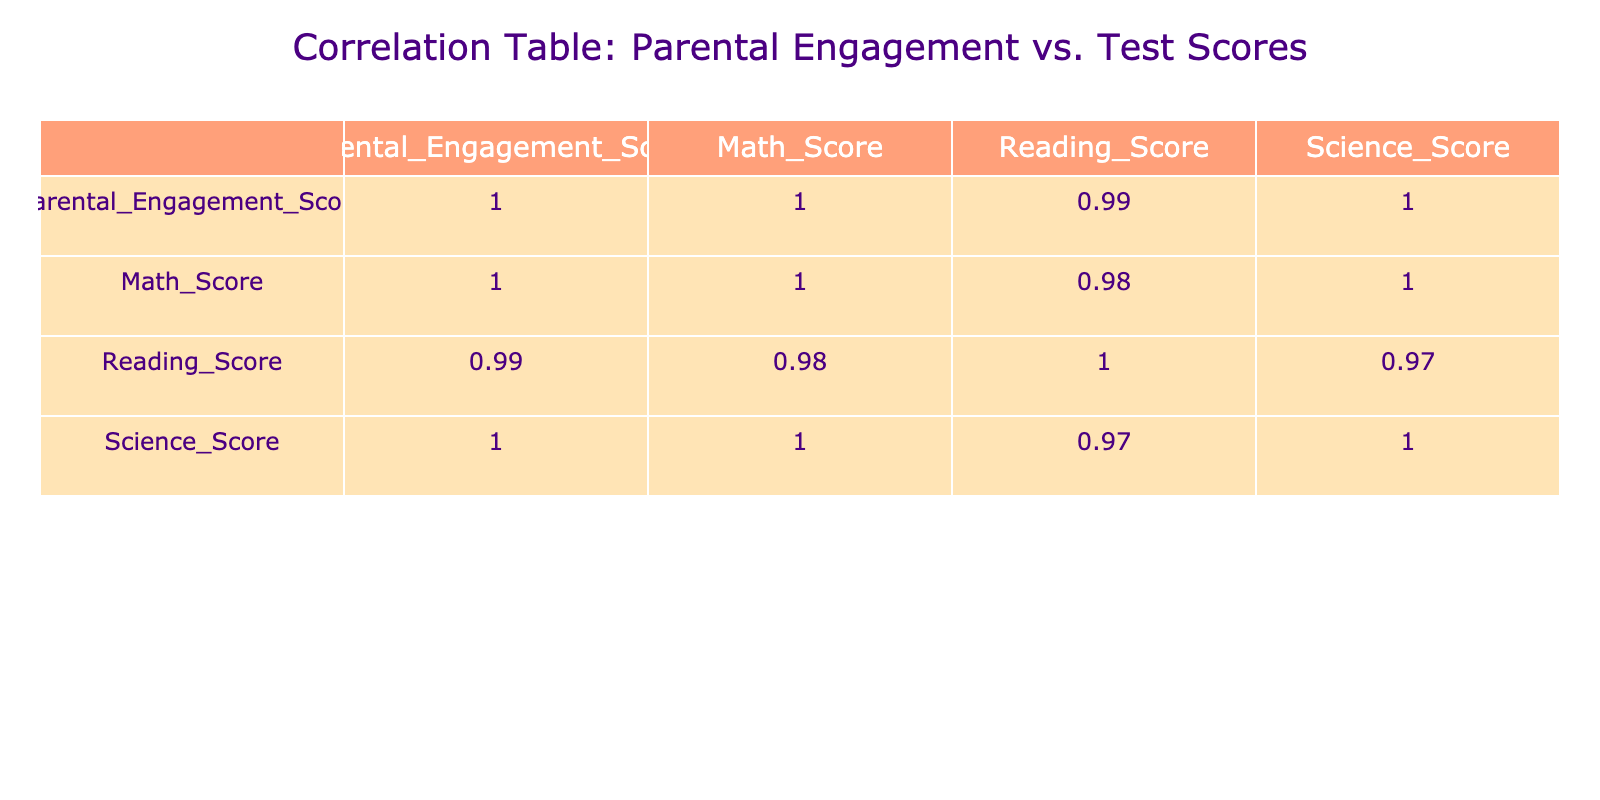What is the correlation between Parental Engagement Score and Math Score? According to the correlation matrix, the value in the row for Parental Engagement Score and the column for Math Score is 0.93. This indicates a strong positive correlation, meaning as parental engagement increases, math scores tend to increase as well.
Answer: 0.93 What is the lowest score for Science among the students with the highest Parental Engagement Score? The highest Parental Engagement Score in the table is 9.5, which corresponds to a Science Score of 99 based on the data point. Therefore, the lowest Science score among those with the highest engagement is the same, which can be referred to as the highest engagement score.
Answer: 99 Is there a negative correlation between Parental Engagement Score and Reading Score? Looking at the correlation value between Parental Engagement Score and Reading Score, it is 0.89, which indicates a strong positive correlation, not a negative one. Therefore, the statement is false.
Answer: No What are the average scores for Math among students with a Parental Engagement Score above 8? The students with a Parental Engagement Score above 8 are 8.5, 9.0, 9.5, and 8.2 with Math Scores of 90, 95, 98, and 88 respectively. Adding these up gives 90 + 95 + 98 + 88 = 371, and dividing by 4 gives an average of 371/4 = 92.75.
Answer: 92.75 Is there a student who scored 60 in Math? By checking the Math Scores in the table, we find that the only student with a score of 60 corresponds to a Parental Engagement Score of 5.5. Thus, the answer is yes.
Answer: Yes What is the correlation between Science Score and Reading Score? The correlation value in the table for Science Score and Reading Score is 0.86. This indicates a strong positive correlation, suggesting that as scores in one subject increase, scores in the other subject tend to increase as well.
Answer: 0.86 What is the difference between the highest and lowest Reading Scores? The highest Reading Score is 97 and the lowest is 62. To find the difference, we subtract the lowest score from the highest: 97 - 62 = 35. Therefore, the difference between the highest and lowest Reading Scores is 35.
Answer: 35 Which subject has the highest correlation with Parental Engagement Score? Looking at the correlation values for all subjects with Parental Engagement Score, Math Score has the highest correlation at 0.93, followed closely by Reading Score at 0.89 and Science Score at 0.87. Thus, Math has the highest correlation.
Answer: Math 